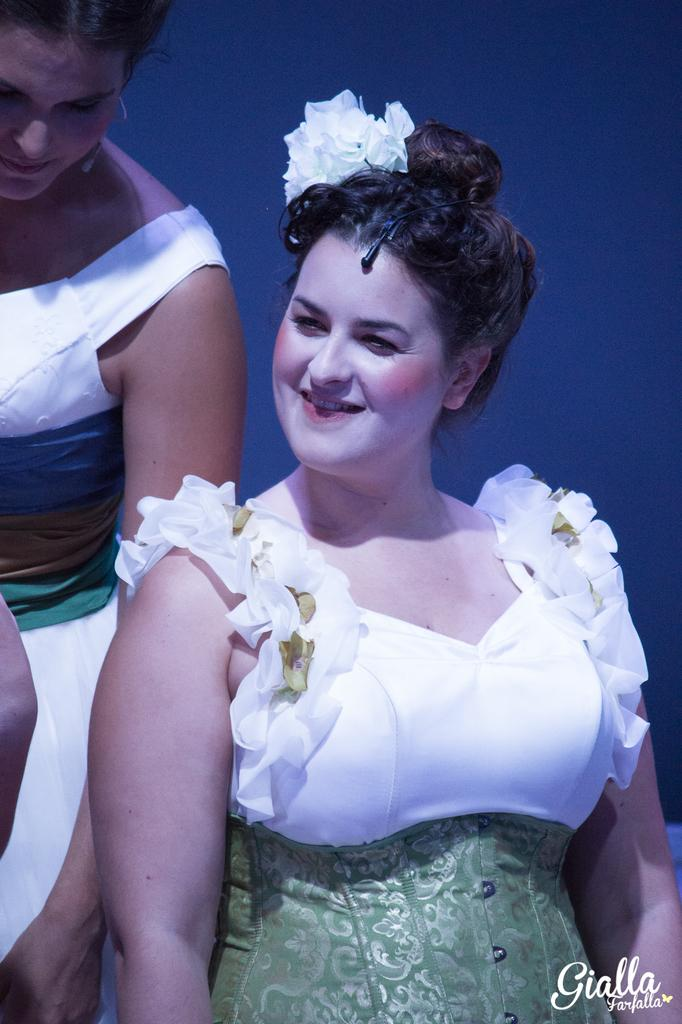How many people are in the image? There are two women in the picture. What are the women wearing? The women are wearing multi-color dresses. What are the women doing in the image? The women are standing and smiling. What type of vase can be seen in the background of the image? There is no vase present in the image. How much coal is visible in the image? There is no coal present in the image. 